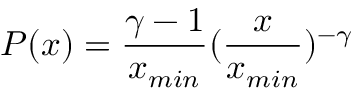Convert formula to latex. <formula><loc_0><loc_0><loc_500><loc_500>P ( x ) = \frac { \gamma - 1 } { x _ { \min } } ( \frac { x } { x _ { \min } } ) ^ { - \gamma }</formula> 